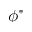Convert formula to latex. <formula><loc_0><loc_0><loc_500><loc_500>\phi ^ { \ast }</formula> 